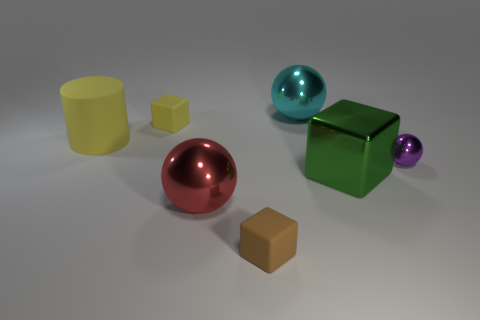How many other objects are the same color as the small ball?
Your answer should be very brief. 0. How many blue cylinders are there?
Offer a terse response. 0. Is the number of cyan shiny spheres that are to the right of the small metal sphere less than the number of tiny yellow cylinders?
Offer a very short reply. No. Do the big ball behind the tiny sphere and the purple object have the same material?
Your answer should be very brief. Yes. What is the shape of the small rubber thing to the right of the big sphere that is on the left side of the rubber block in front of the big red shiny object?
Provide a succinct answer. Cube. Is there a yellow block of the same size as the purple sphere?
Offer a very short reply. Yes. What size is the purple ball?
Your response must be concise. Small. What number of yellow matte things are the same size as the brown thing?
Offer a terse response. 1. Is the number of yellow cubes that are in front of the small purple shiny ball less than the number of big objects behind the big green block?
Your response must be concise. Yes. There is a rubber cylinder that is on the left side of the block that is on the right side of the metallic object behind the large rubber object; what size is it?
Provide a short and direct response. Large. 